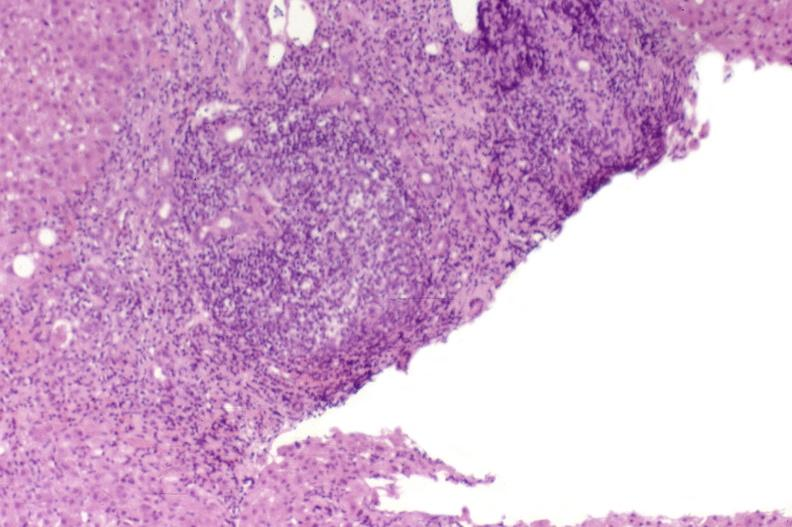what is present?
Answer the question using a single word or phrase. Liver 